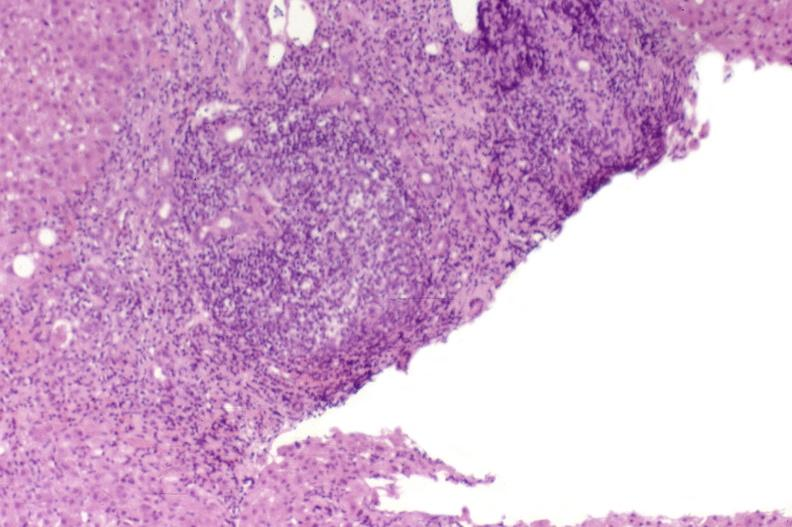what is present?
Answer the question using a single word or phrase. Liver 